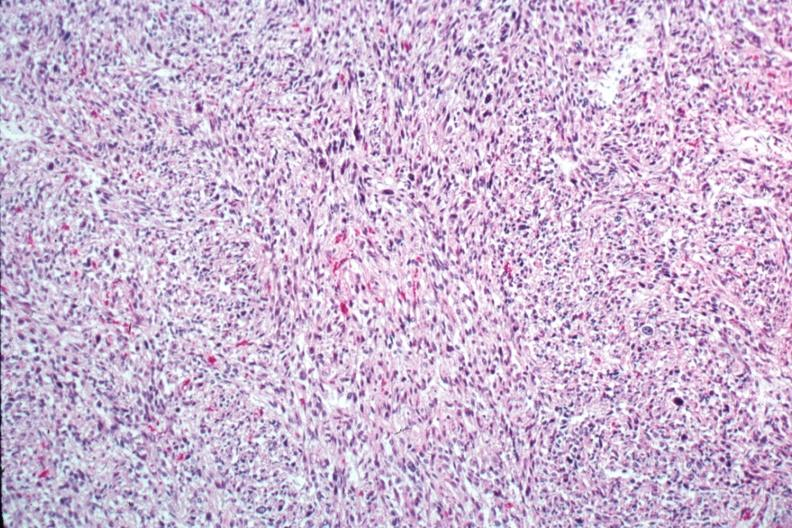s uterus present?
Answer the question using a single word or phrase. Yes 